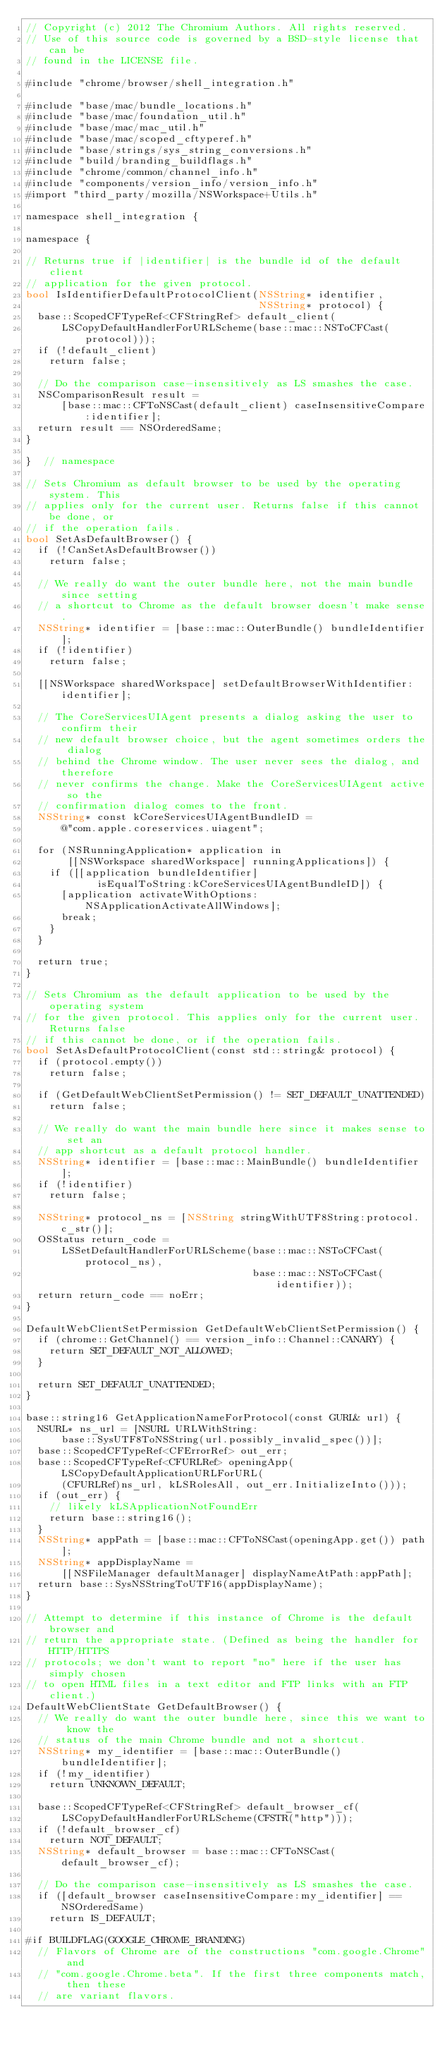<code> <loc_0><loc_0><loc_500><loc_500><_ObjectiveC_>// Copyright (c) 2012 The Chromium Authors. All rights reserved.
// Use of this source code is governed by a BSD-style license that can be
// found in the LICENSE file.

#include "chrome/browser/shell_integration.h"

#include "base/mac/bundle_locations.h"
#include "base/mac/foundation_util.h"
#include "base/mac/mac_util.h"
#include "base/mac/scoped_cftyperef.h"
#include "base/strings/sys_string_conversions.h"
#include "build/branding_buildflags.h"
#include "chrome/common/channel_info.h"
#include "components/version_info/version_info.h"
#import "third_party/mozilla/NSWorkspace+Utils.h"

namespace shell_integration {

namespace {

// Returns true if |identifier| is the bundle id of the default client
// application for the given protocol.
bool IsIdentifierDefaultProtocolClient(NSString* identifier,
                                       NSString* protocol) {
  base::ScopedCFTypeRef<CFStringRef> default_client(
      LSCopyDefaultHandlerForURLScheme(base::mac::NSToCFCast(protocol)));
  if (!default_client)
    return false;

  // Do the comparison case-insensitively as LS smashes the case.
  NSComparisonResult result =
      [base::mac::CFToNSCast(default_client) caseInsensitiveCompare:identifier];
  return result == NSOrderedSame;
}

}  // namespace

// Sets Chromium as default browser to be used by the operating system. This
// applies only for the current user. Returns false if this cannot be done, or
// if the operation fails.
bool SetAsDefaultBrowser() {
  if (!CanSetAsDefaultBrowser())
    return false;

  // We really do want the outer bundle here, not the main bundle since setting
  // a shortcut to Chrome as the default browser doesn't make sense.
  NSString* identifier = [base::mac::OuterBundle() bundleIdentifier];
  if (!identifier)
    return false;

  [[NSWorkspace sharedWorkspace] setDefaultBrowserWithIdentifier:identifier];

  // The CoreServicesUIAgent presents a dialog asking the user to confirm their
  // new default browser choice, but the agent sometimes orders the dialog
  // behind the Chrome window. The user never sees the dialog, and therefore
  // never confirms the change. Make the CoreServicesUIAgent active so the
  // confirmation dialog comes to the front.
  NSString* const kCoreServicesUIAgentBundleID =
      @"com.apple.coreservices.uiagent";

  for (NSRunningApplication* application in
       [[NSWorkspace sharedWorkspace] runningApplications]) {
    if ([[application bundleIdentifier]
            isEqualToString:kCoreServicesUIAgentBundleID]) {
      [application activateWithOptions:NSApplicationActivateAllWindows];
      break;
    }
  }

  return true;
}

// Sets Chromium as the default application to be used by the operating system
// for the given protocol. This applies only for the current user. Returns false
// if this cannot be done, or if the operation fails.
bool SetAsDefaultProtocolClient(const std::string& protocol) {
  if (protocol.empty())
    return false;

  if (GetDefaultWebClientSetPermission() != SET_DEFAULT_UNATTENDED)
    return false;

  // We really do want the main bundle here since it makes sense to set an
  // app shortcut as a default protocol handler.
  NSString* identifier = [base::mac::MainBundle() bundleIdentifier];
  if (!identifier)
    return false;

  NSString* protocol_ns = [NSString stringWithUTF8String:protocol.c_str()];
  OSStatus return_code =
      LSSetDefaultHandlerForURLScheme(base::mac::NSToCFCast(protocol_ns),
                                      base::mac::NSToCFCast(identifier));
  return return_code == noErr;
}

DefaultWebClientSetPermission GetDefaultWebClientSetPermission() {
  if (chrome::GetChannel() == version_info::Channel::CANARY) {
    return SET_DEFAULT_NOT_ALLOWED;
  }

  return SET_DEFAULT_UNATTENDED;
}

base::string16 GetApplicationNameForProtocol(const GURL& url) {
  NSURL* ns_url = [NSURL URLWithString:
      base::SysUTF8ToNSString(url.possibly_invalid_spec())];
  base::ScopedCFTypeRef<CFErrorRef> out_err;
  base::ScopedCFTypeRef<CFURLRef> openingApp(LSCopyDefaultApplicationURLForURL(
      (CFURLRef)ns_url, kLSRolesAll, out_err.InitializeInto()));
  if (out_err) {
    // likely kLSApplicationNotFoundErr
    return base::string16();
  }
  NSString* appPath = [base::mac::CFToNSCast(openingApp.get()) path];
  NSString* appDisplayName =
      [[NSFileManager defaultManager] displayNameAtPath:appPath];
  return base::SysNSStringToUTF16(appDisplayName);
}

// Attempt to determine if this instance of Chrome is the default browser and
// return the appropriate state. (Defined as being the handler for HTTP/HTTPS
// protocols; we don't want to report "no" here if the user has simply chosen
// to open HTML files in a text editor and FTP links with an FTP client.)
DefaultWebClientState GetDefaultBrowser() {
  // We really do want the outer bundle here, since this we want to know the
  // status of the main Chrome bundle and not a shortcut.
  NSString* my_identifier = [base::mac::OuterBundle() bundleIdentifier];
  if (!my_identifier)
    return UNKNOWN_DEFAULT;

  base::ScopedCFTypeRef<CFStringRef> default_browser_cf(
      LSCopyDefaultHandlerForURLScheme(CFSTR("http")));
  if (!default_browser_cf)
    return NOT_DEFAULT;
  NSString* default_browser = base::mac::CFToNSCast(default_browser_cf);

  // Do the comparison case-insensitively as LS smashes the case.
  if ([default_browser caseInsensitiveCompare:my_identifier] == NSOrderedSame)
    return IS_DEFAULT;

#if BUILDFLAG(GOOGLE_CHROME_BRANDING)
  // Flavors of Chrome are of the constructions "com.google.Chrome" and
  // "com.google.Chrome.beta". If the first three components match, then these
  // are variant flavors.</code> 